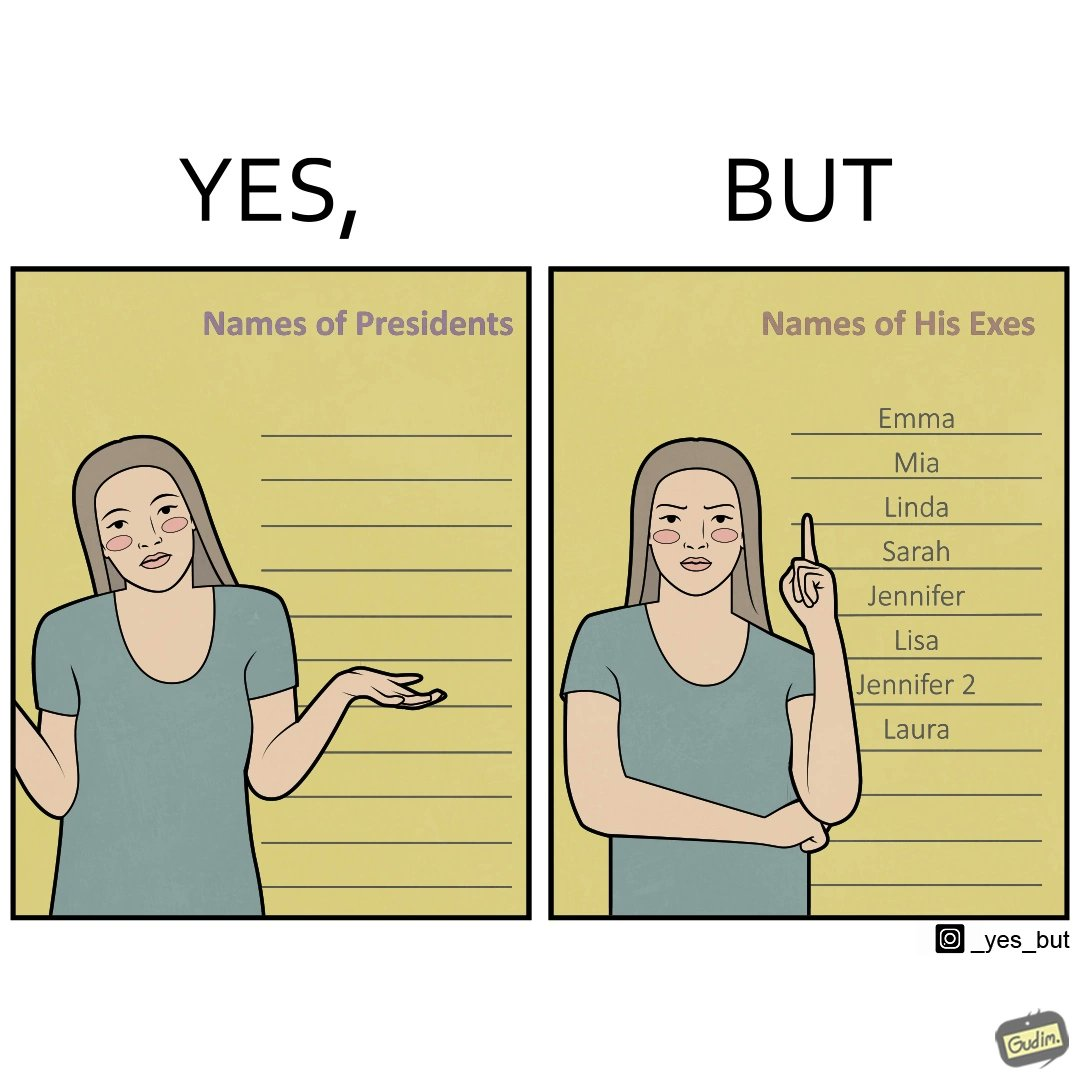Why is this image considered satirical? The images are funny since it shows how people tend to forget the important details like names of presidents but remember the useless ones, like forgetting names of presidents but remembering the names of their exes in this example 